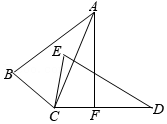Can you explain how the congruence of triangles ABC and DEC affects the interior angles of the triangles? Certainly! Since triangles ABC and DEC are congruent, each angle in triangle ABC has a matching angle in triangle DEC with the same measure. Specifically, angle A in triangle ABC corresponds to angle D, angle B corresponds to angle E, and angle C corresponds to angle C. This congruency establishes that any properties or calculations derived from the angles of one triangle directly apply to the other. For instance, any time you perform a calculation involving an angle of triangle ABC, you can assume the corresponding angle in triangle DEC will mirror that calculation. This is crucial for solving various geometric problems involving these triangles. 